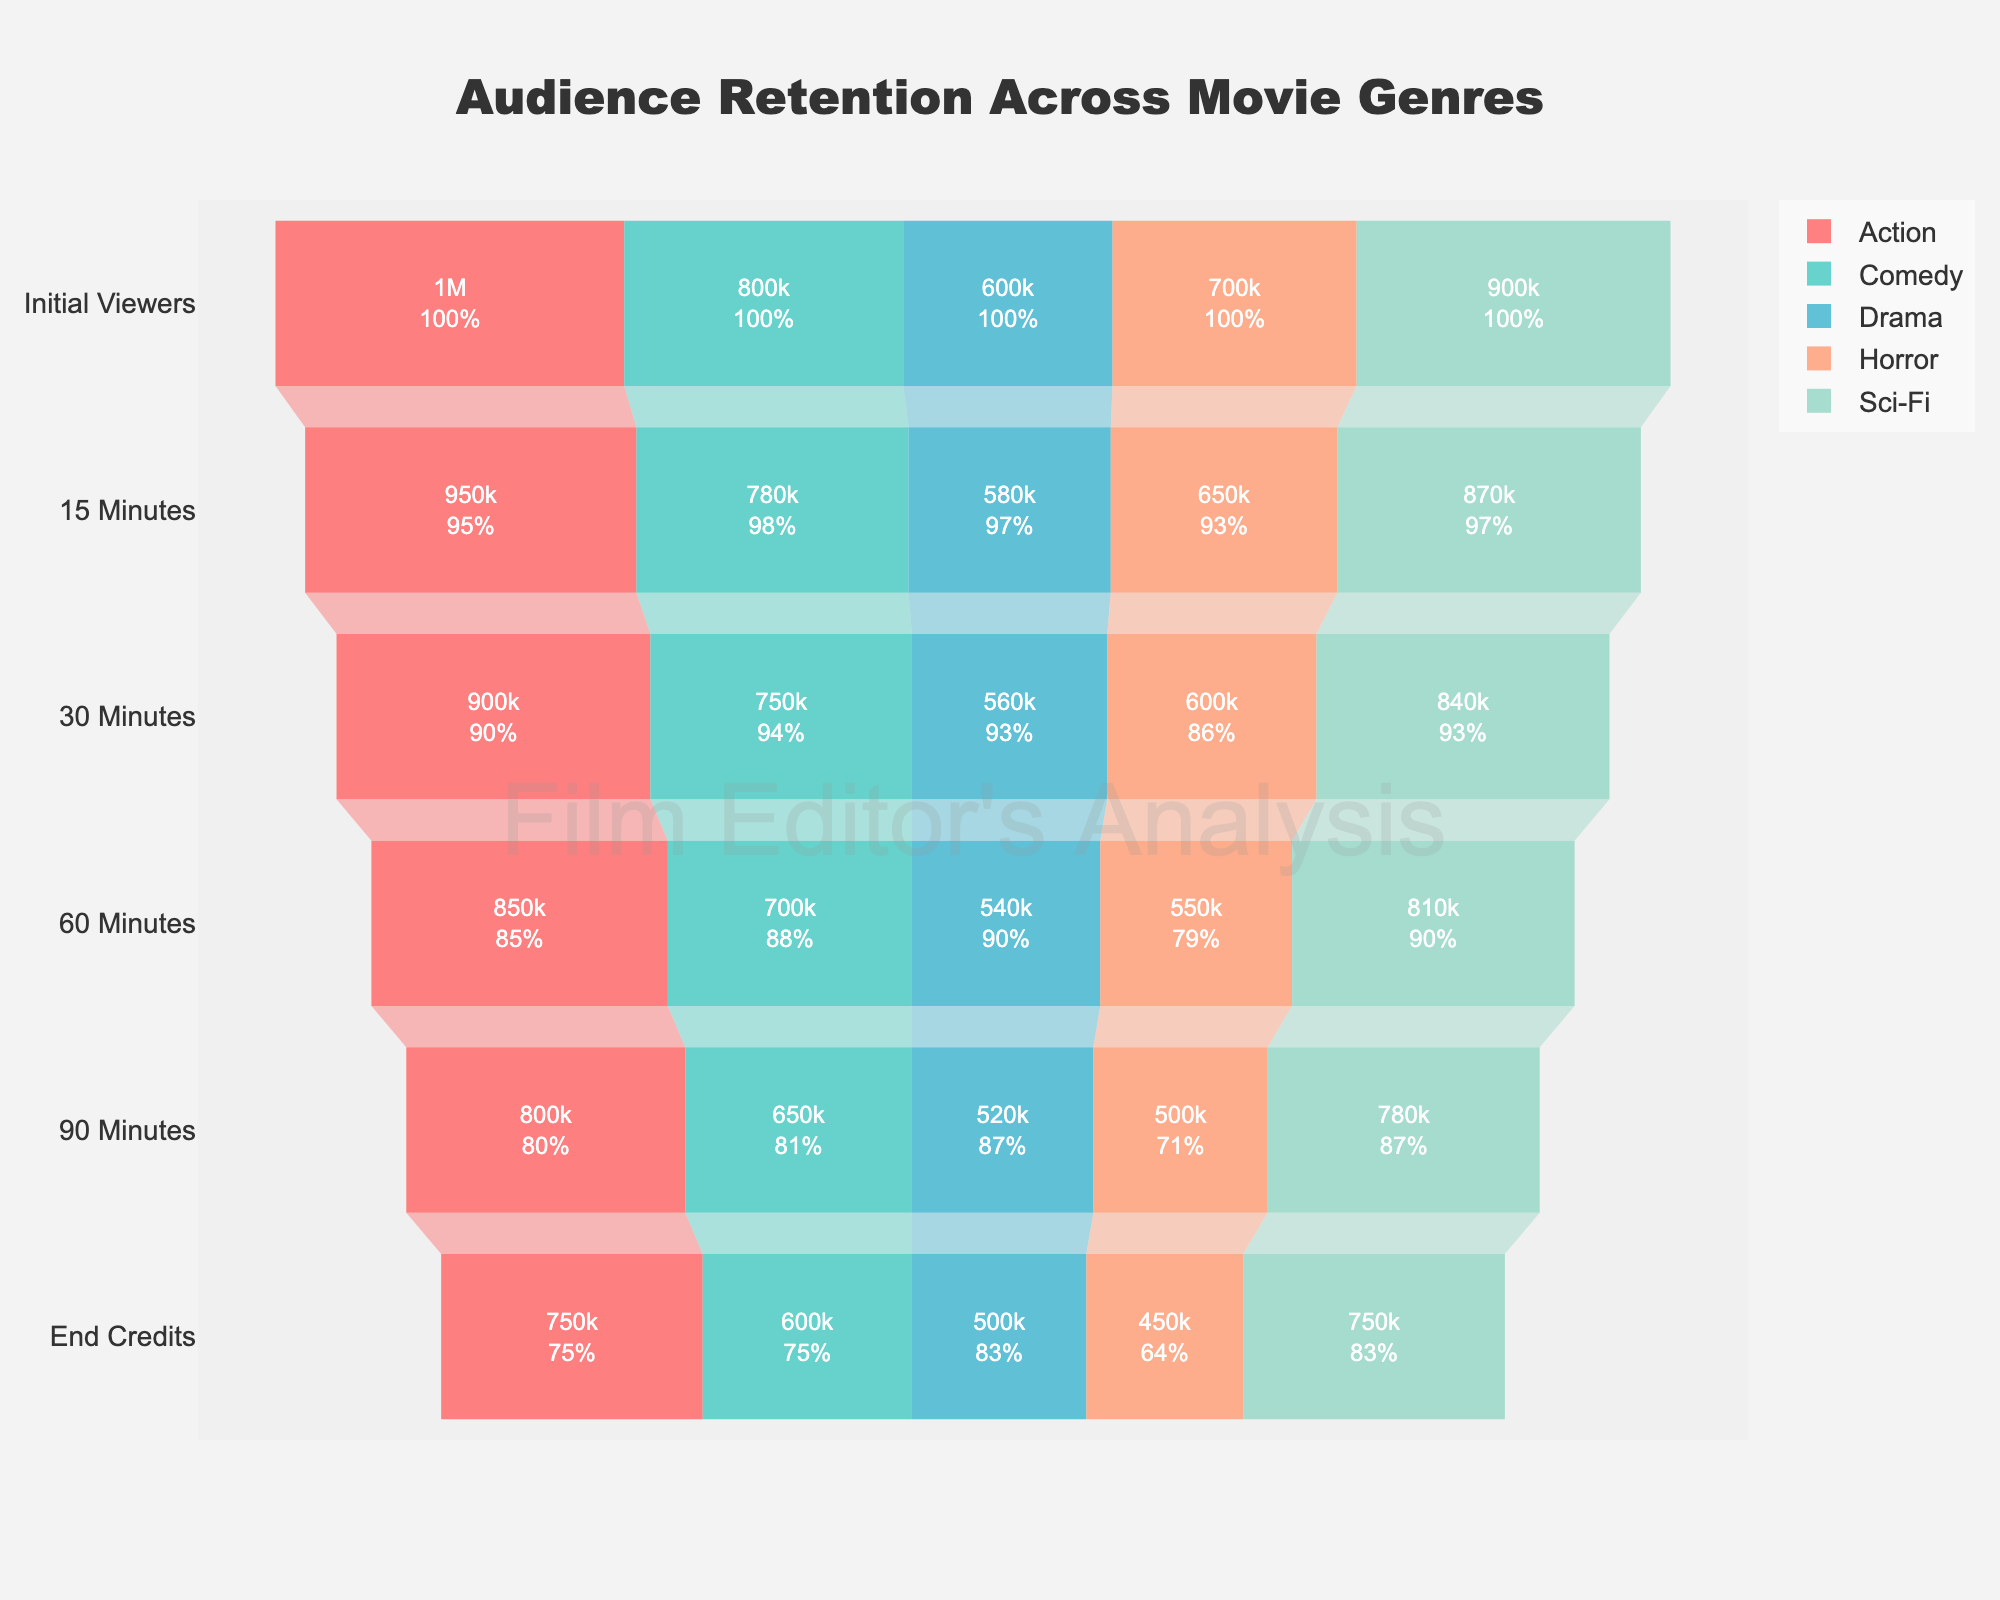At which stage does the Action genre have the most significant drop in viewers? To find the most significant drop, compare the number of viewers between consecutive stages for the Action genre. The biggest drop is from Initial Viewers (1000000) to 15 Minutes (950000), a drop of 50000 viewers.
Answer: Initial Viewers to 15 Minutes Which genre retains the highest percentage of its initial viewers by the End Credits? Calculate the percentage of viewers retained at the End Credits for each genre. Sci-Fi retains (750000/900000) approximately 83.33%, which is the highest.
Answer: Sci-Fi How many viewers did the Comedy genre lose between 30 Minutes and 90 Minutes? Subtract the number of viewers at 90 Minutes (650000) from the number at 30 Minutes (750000). The Comedy genre loses 100000 viewers.
Answer: 100000 Which genre has the smallest decrease in viewers from 60 Minutes to 90 Minutes? Compare the number of viewers between 60 Minutes and 90 Minutes for each genre. The smallest decrease is in the Sci-Fi genre, which decreases from 810000 to 780000, a drop of 30000 viewers.
Answer: Sci-Fi What is the total number of viewers lost by the Horror genre from Initial Viewers to End Credits? Subtract the number of viewers at End Credits (450000) from the Initial Viewers (700000). The Horror genre loses a total of 250000 viewers.
Answer: 250000 Which genres have at least 750000 viewers by the 60 Minutes stage? Look at the number of viewers at the 60 Minutes stage for each genre. Action (850000) and Sci-Fi (810000) both have at least 750000 viewers.
Answer: Action, Sci-Fi Between Drama and Horror, which genre has a higher retention at the 30 Minutes stage? Compare the number of viewers at 30 Minutes for Drama (560000) and Horror (600000). Horror has higher retention.
Answer: Horror What percentage of viewers does the Comedy genre retain from Initial Viewers to 15 Minutes? Calculate (780000/800000) * 100% to find that the Comedy genre retains 97.5% of its initial viewers at 15 Minutes.
Answer: 97.5% How does the retention rate change from 30 Minutes to End Credits for the Drama genre? Percentage drop is (560000 - 500000)/560000 * 100% ≈ 10.71%. Compare the viewers in these stages to find the decrease.
Answer: 10.71% Which genre has the largest number of viewers at the 90 Minutes mark? Compare the number of viewers at 90 Minutes for each genre. Action has the most viewers with 800000.
Answer: Action 